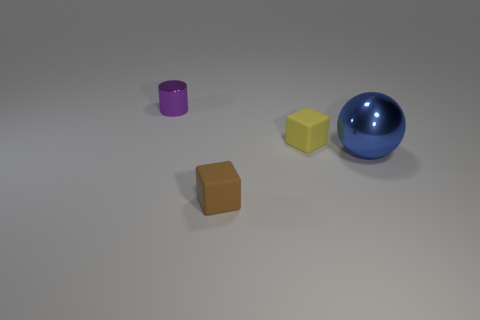Add 4 blue metal balls. How many objects exist? 8 Subtract all cylinders. How many objects are left? 3 Subtract all cyan cylinders. Subtract all small brown objects. How many objects are left? 3 Add 4 blue metallic spheres. How many blue metallic spheres are left? 5 Add 1 large gray shiny cylinders. How many large gray shiny cylinders exist? 1 Subtract 0 brown spheres. How many objects are left? 4 